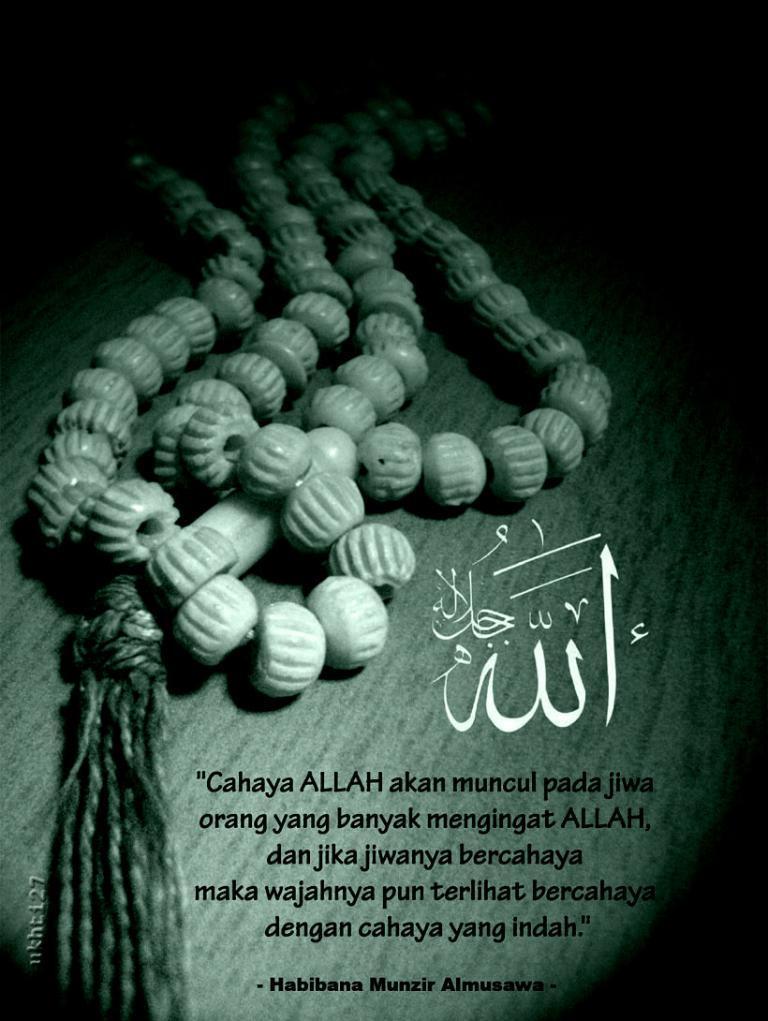Can you describe this image briefly? In this picture, we see a chain which is made up of beads. At the bottom of the picture, we see some text written. In the background, it is black in color. This picture is clicked in the dark and this might be a poster. 